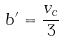<formula> <loc_0><loc_0><loc_500><loc_500>b ^ { \prime } = \frac { v _ { c } } { 3 }</formula> 